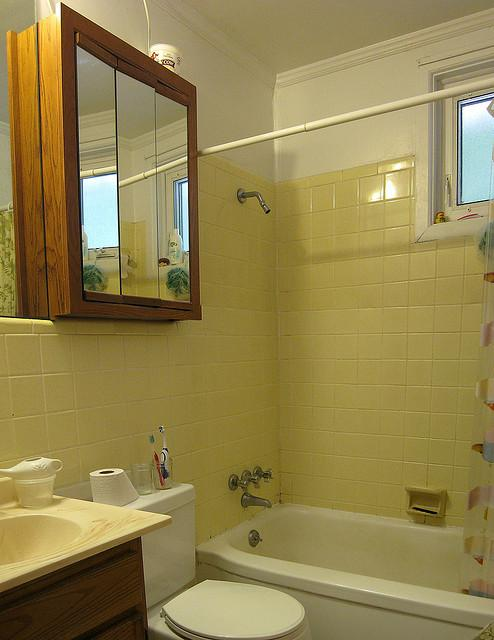What happens behind the curtain? bathing 